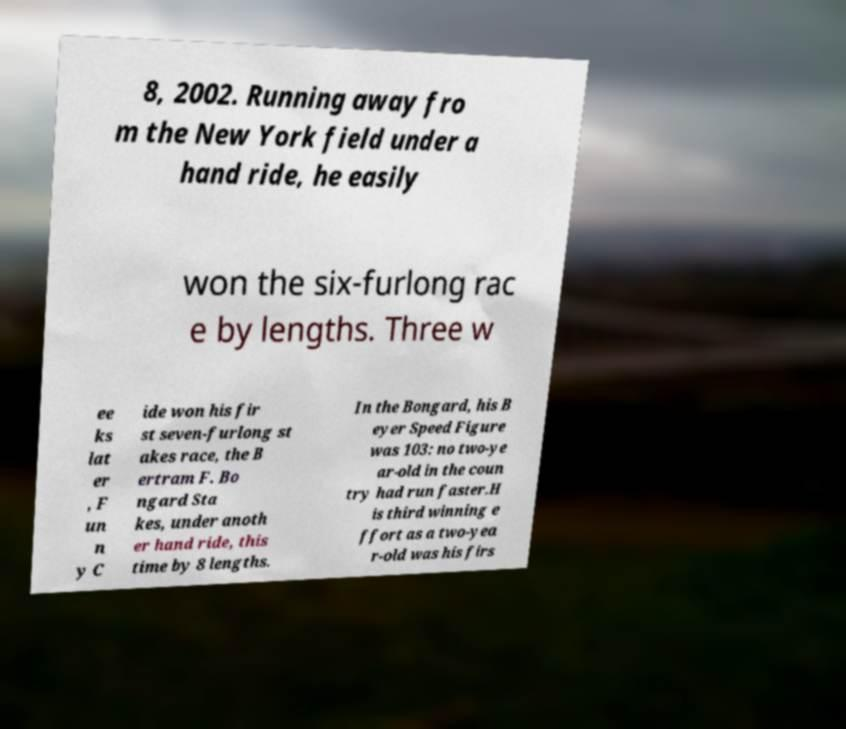Can you accurately transcribe the text from the provided image for me? 8, 2002. Running away fro m the New York field under a hand ride, he easily won the six-furlong rac e by lengths. Three w ee ks lat er , F un n y C ide won his fir st seven-furlong st akes race, the B ertram F. Bo ngard Sta kes, under anoth er hand ride, this time by 8 lengths. In the Bongard, his B eyer Speed Figure was 103: no two-ye ar-old in the coun try had run faster.H is third winning e ffort as a two-yea r-old was his firs 